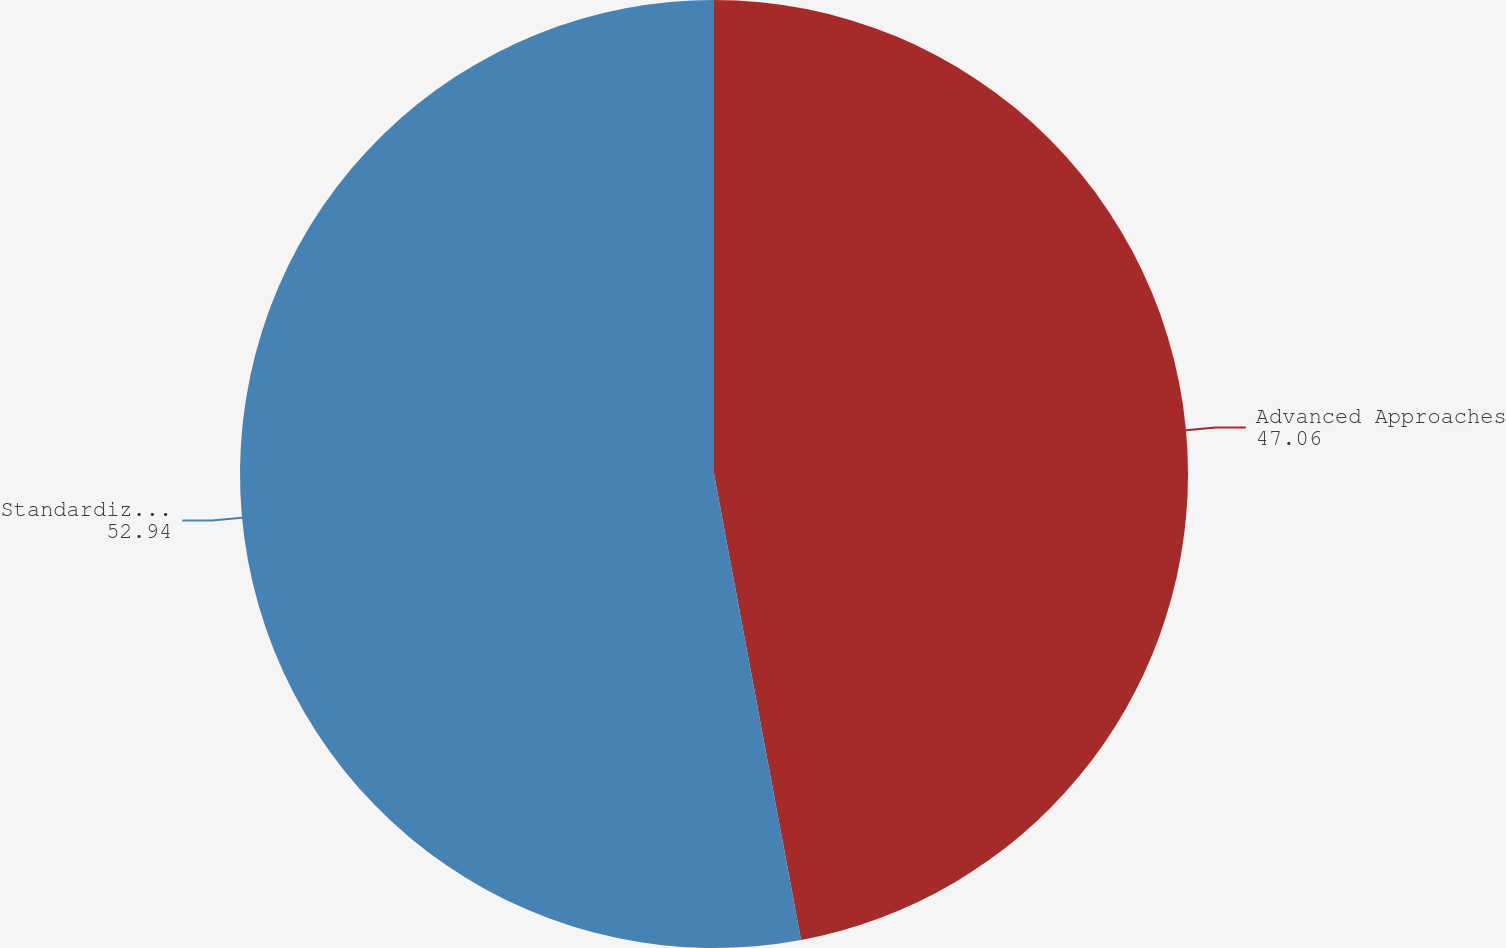Convert chart. <chart><loc_0><loc_0><loc_500><loc_500><pie_chart><fcel>Advanced Approaches<fcel>Standardized Approach<nl><fcel>47.06%<fcel>52.94%<nl></chart> 